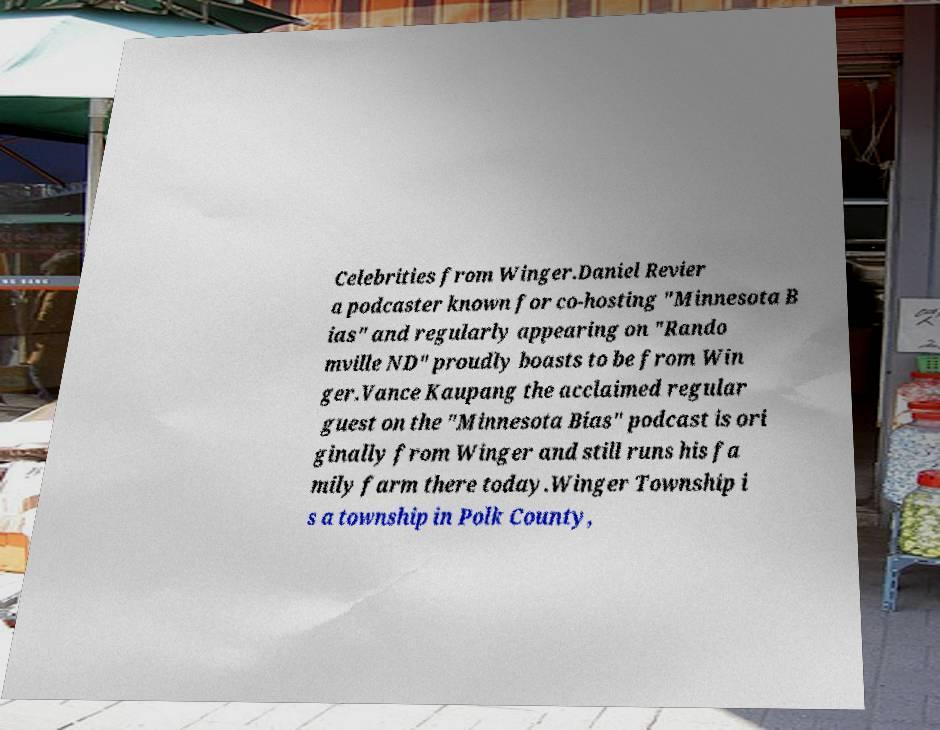What messages or text are displayed in this image? I need them in a readable, typed format. Celebrities from Winger.Daniel Revier a podcaster known for co-hosting "Minnesota B ias" and regularly appearing on "Rando mville ND" proudly boasts to be from Win ger.Vance Kaupang the acclaimed regular guest on the "Minnesota Bias" podcast is ori ginally from Winger and still runs his fa mily farm there today.Winger Township i s a township in Polk County, 